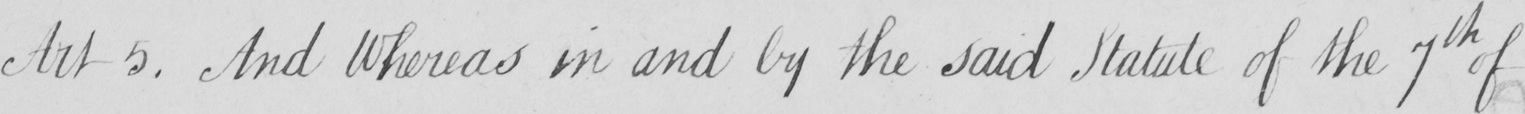Please transcribe the handwritten text in this image. And Whereas in and by the said Statute of the 7th of 